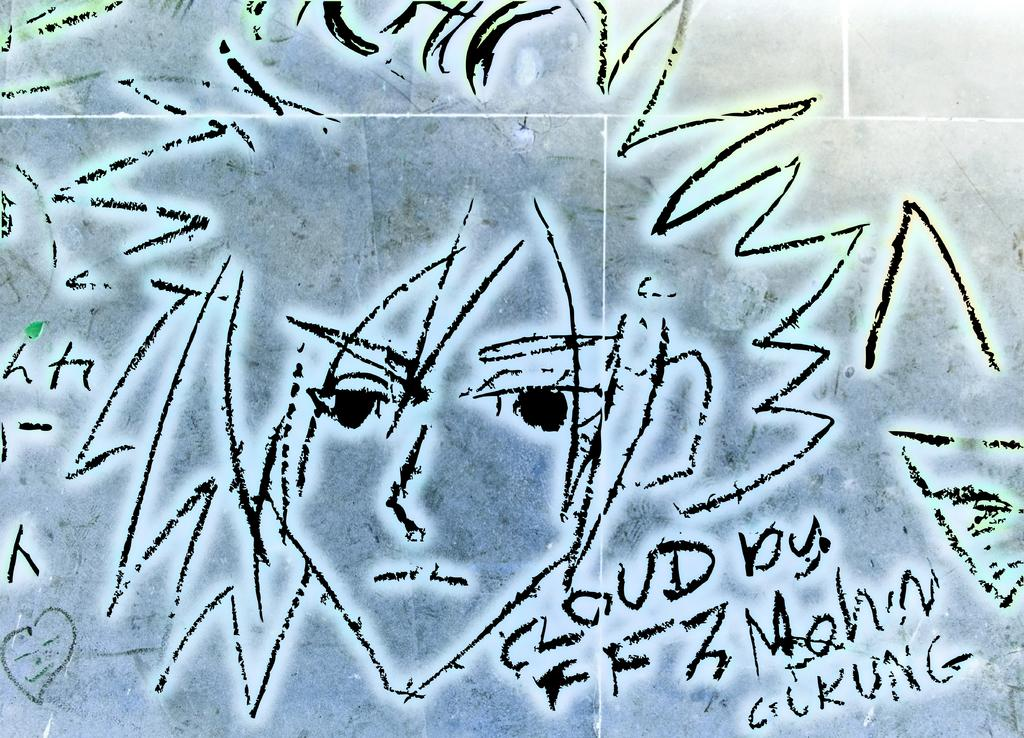What is displayed on the wall in the image? There is an art piece on the wall in the image. What is depicted in the art piece? The art piece includes a human face. Are there any additional elements in the art piece? Yes, there is writing on the art piece. How many matches are arranged in a quiver in the image? There are no matches or quivers present in the image; it features an art piece with a human face and writing. 